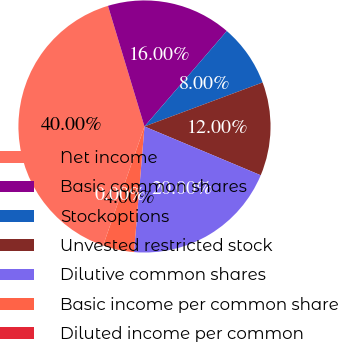<chart> <loc_0><loc_0><loc_500><loc_500><pie_chart><fcel>Net income<fcel>Basic common shares<fcel>Stockoptions<fcel>Unvested restricted stock<fcel>Dilutive common shares<fcel>Basic income per common share<fcel>Diluted income per common<nl><fcel>40.0%<fcel>16.0%<fcel>8.0%<fcel>12.0%<fcel>20.0%<fcel>4.0%<fcel>0.0%<nl></chart> 